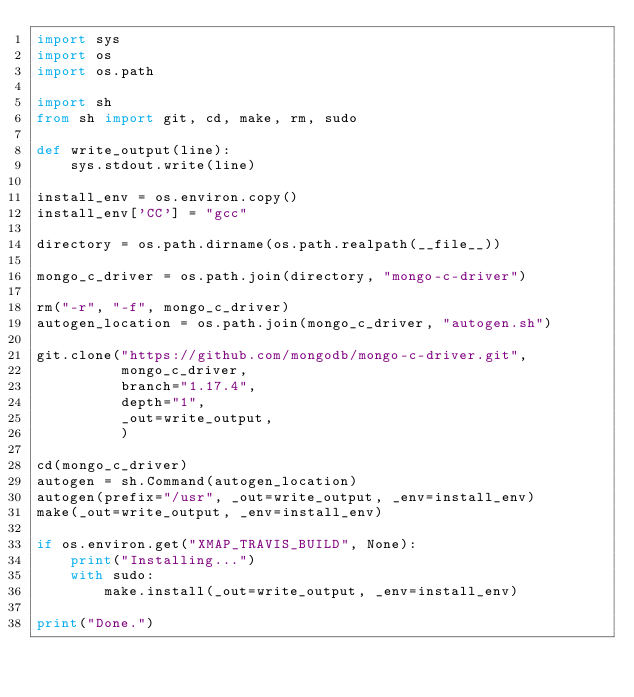<code> <loc_0><loc_0><loc_500><loc_500><_Python_>import sys
import os
import os.path

import sh
from sh import git, cd, make, rm, sudo

def write_output(line):
	sys.stdout.write(line)

install_env = os.environ.copy()
install_env['CC'] = "gcc"

directory = os.path.dirname(os.path.realpath(__file__))

mongo_c_driver = os.path.join(directory, "mongo-c-driver")

rm("-r", "-f", mongo_c_driver)
autogen_location = os.path.join(mongo_c_driver, "autogen.sh")

git.clone("https://github.com/mongodb/mongo-c-driver.git",
		  mongo_c_driver,
		  branch="1.17.4",
		  depth="1",
		  _out=write_output,
		  )

cd(mongo_c_driver)
autogen = sh.Command(autogen_location)
autogen(prefix="/usr", _out=write_output, _env=install_env)
make(_out=write_output, _env=install_env)

if os.environ.get("XMAP_TRAVIS_BUILD", None):
	print("Installing...")
	with sudo:
		make.install(_out=write_output, _env=install_env)

print("Done.")
</code> 